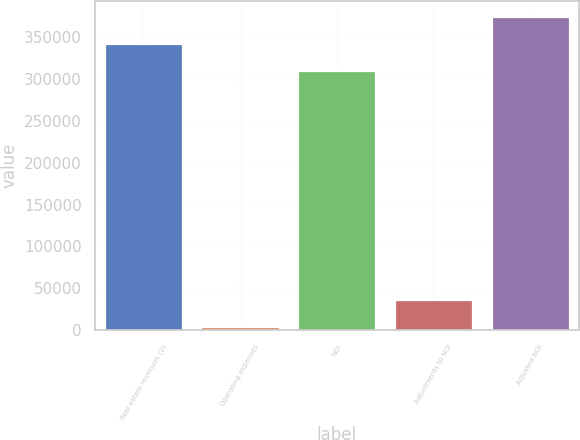Convert chart. <chart><loc_0><loc_0><loc_500><loc_500><bar_chart><fcel>Real estate revenues (2)<fcel>Operating expenses<fcel>NOI<fcel>Adjustments to NOI<fcel>Adjusted NOI<nl><fcel>342029<fcel>3819<fcel>309728<fcel>36119.7<fcel>374329<nl></chart> 